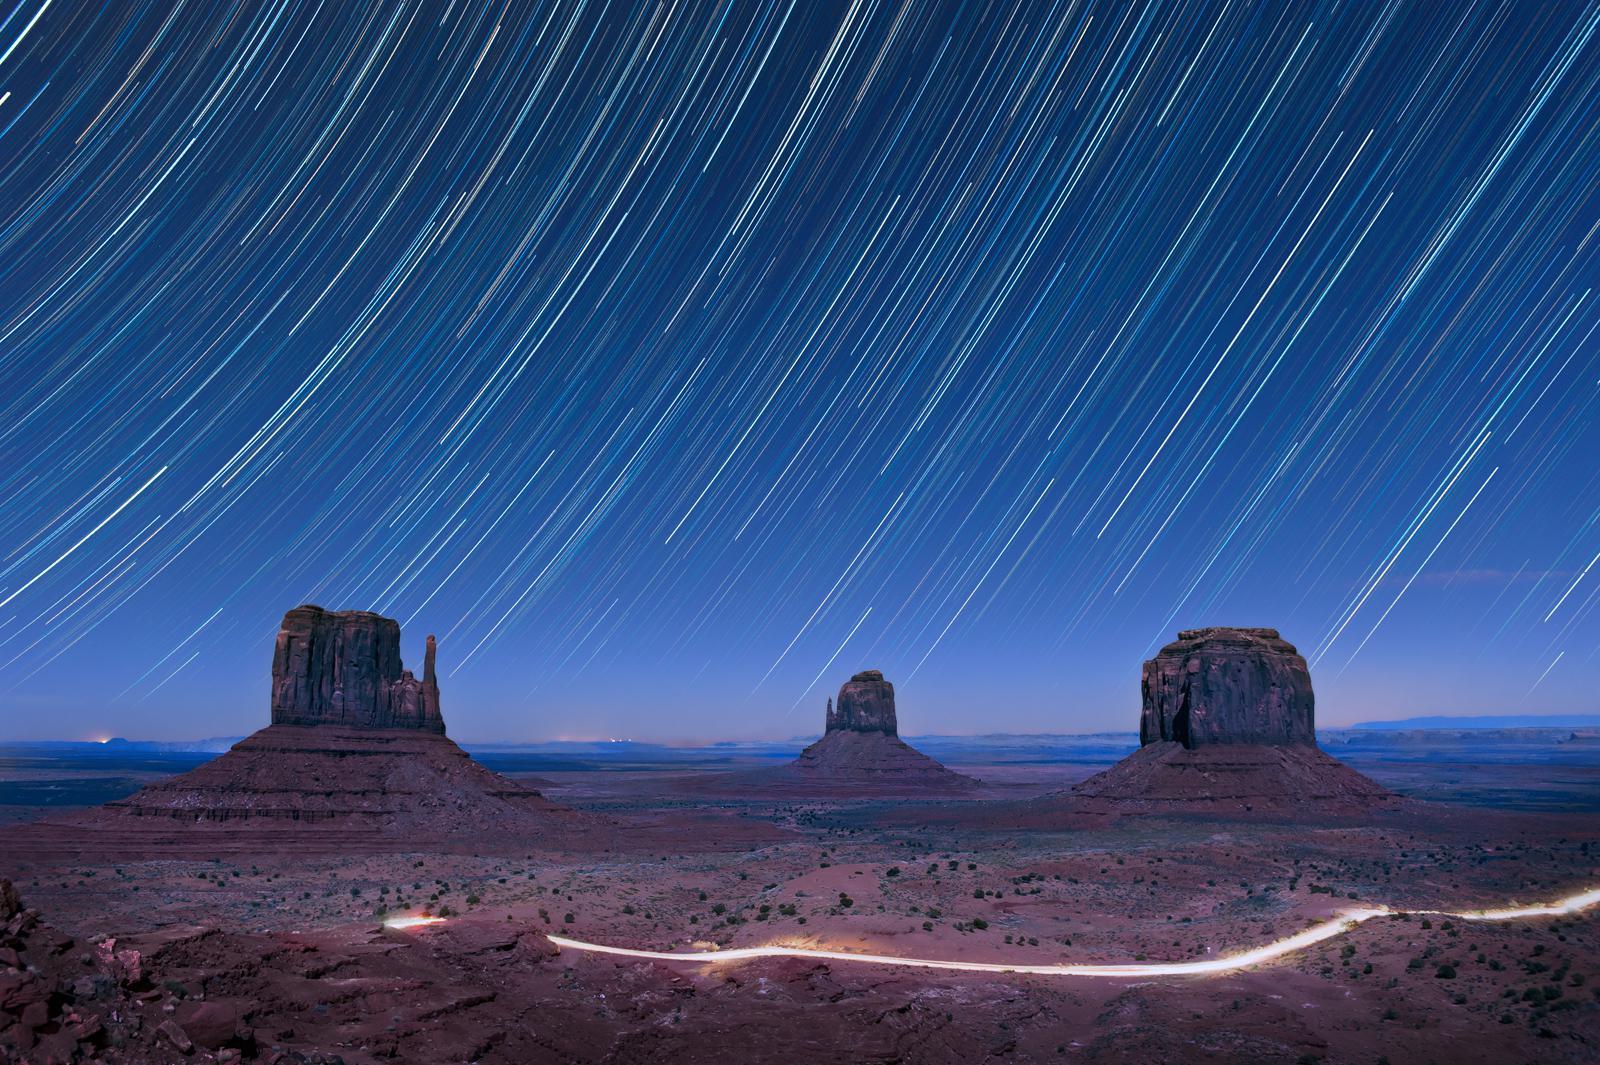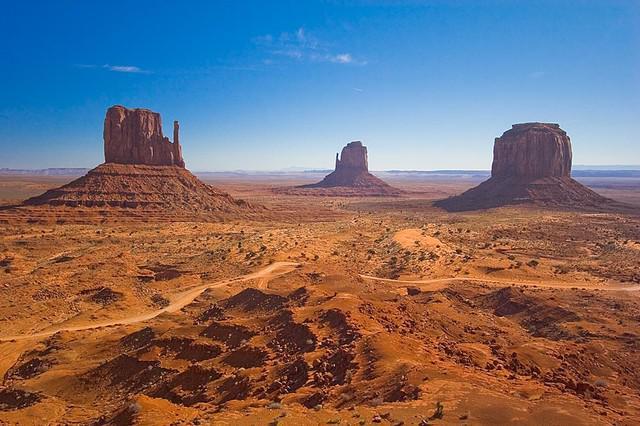The first image is the image on the left, the second image is the image on the right. For the images shown, is this caption "The left and right images show the same view of three rock formations, but under different sky conditions." true? Answer yes or no. Yes. The first image is the image on the left, the second image is the image on the right. Considering the images on both sides, is "In the left image, there is an upright object in the foreground with rock formations behind." valid? Answer yes or no. No. 